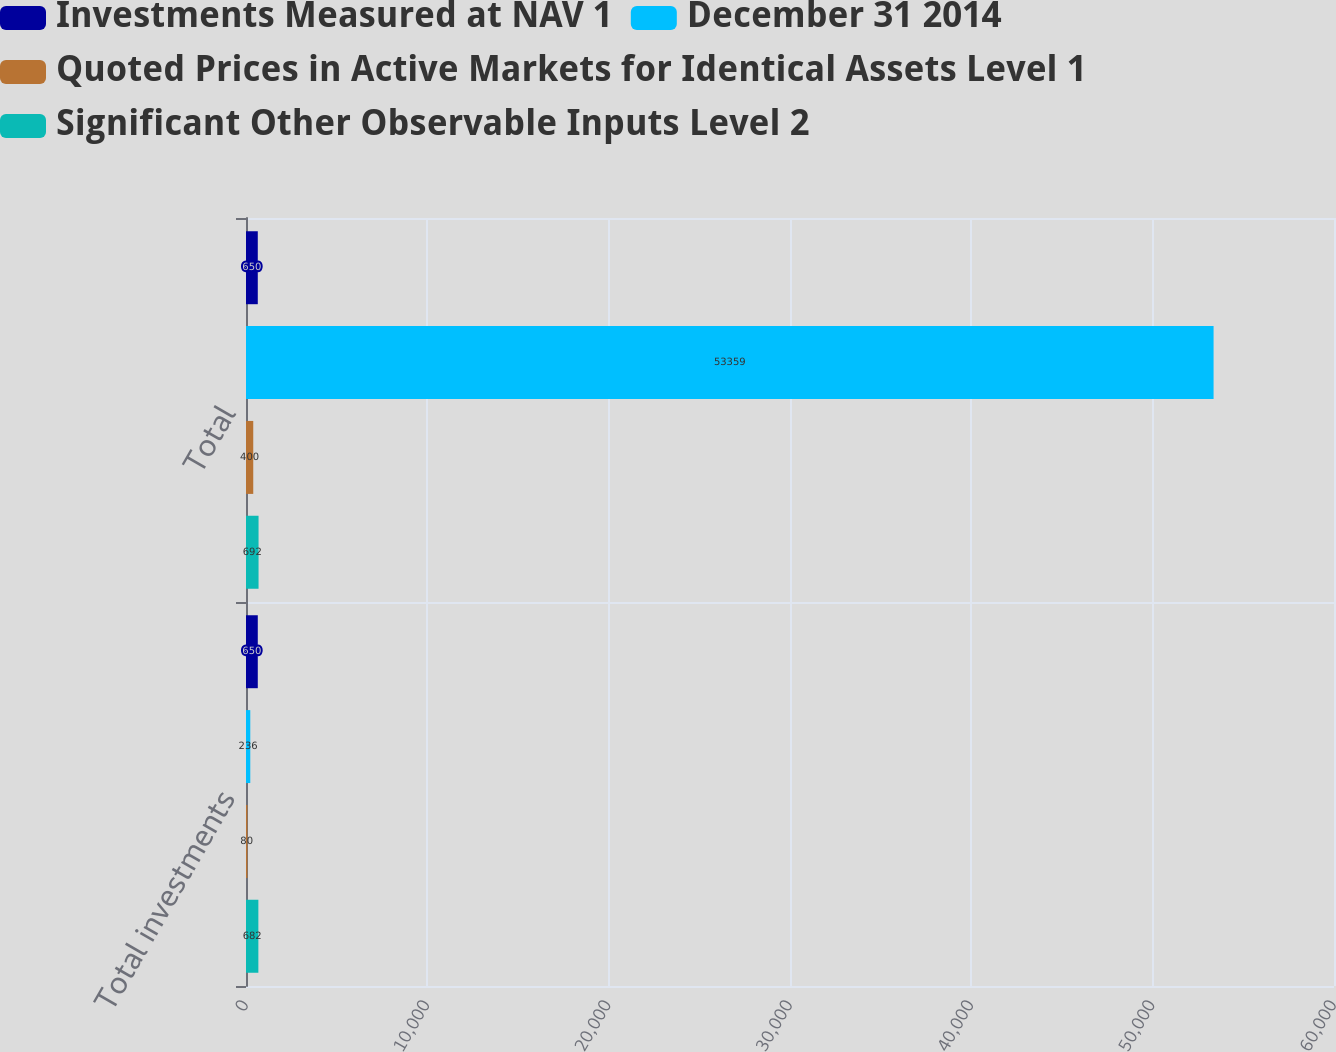Convert chart. <chart><loc_0><loc_0><loc_500><loc_500><stacked_bar_chart><ecel><fcel>Total investments<fcel>Total<nl><fcel>Investments Measured at NAV 1<fcel>650<fcel>650<nl><fcel>December 31 2014<fcel>236<fcel>53359<nl><fcel>Quoted Prices in Active Markets for Identical Assets Level 1<fcel>80<fcel>400<nl><fcel>Significant Other Observable Inputs Level 2<fcel>682<fcel>692<nl></chart> 